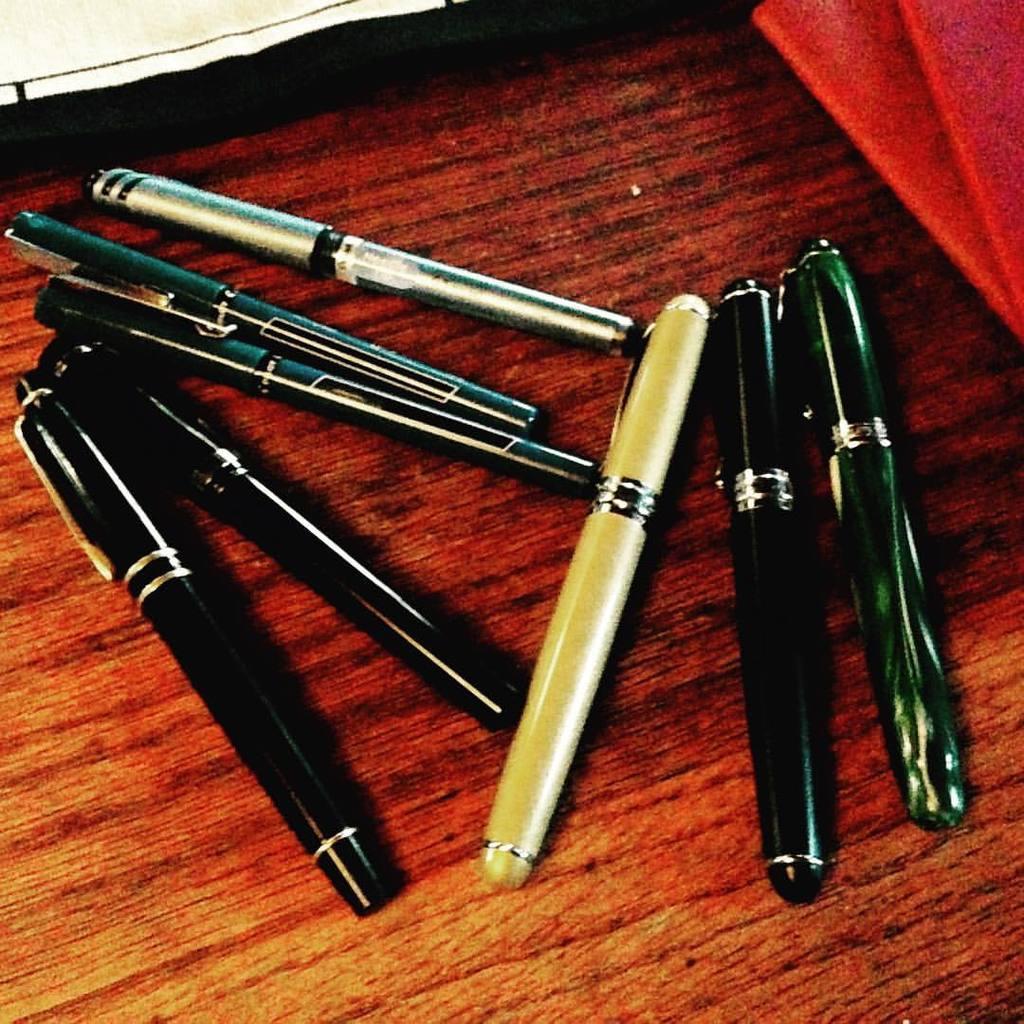Can you describe this image briefly? Here we can see pens on a wooden platform. 